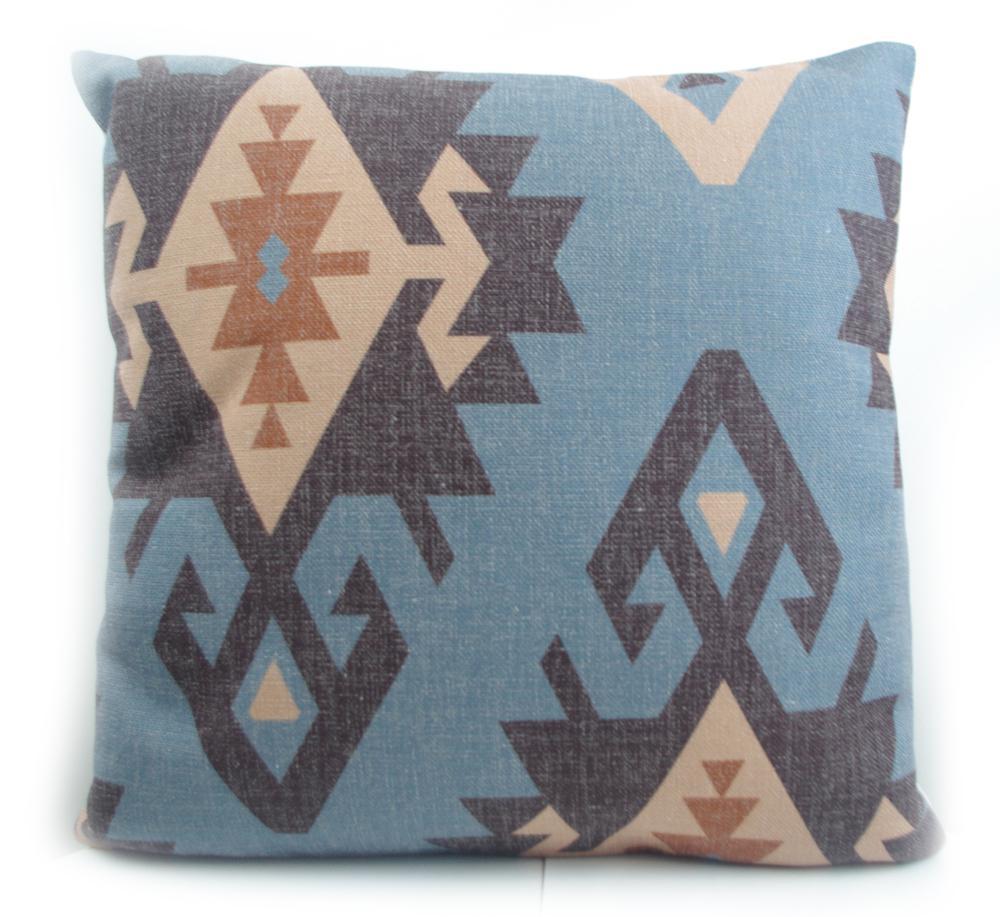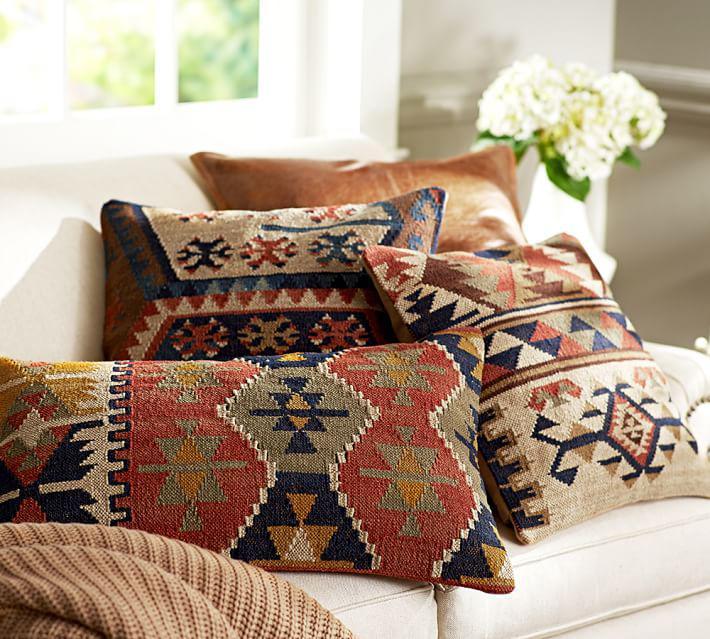The first image is the image on the left, the second image is the image on the right. Assess this claim about the two images: "In at least one image there is only a single pillow standing up with some triangle patterns sewn into it.". Correct or not? Answer yes or no. Yes. The first image is the image on the left, the second image is the image on the right. Assess this claim about the two images: "One image contains a single square pillow with Aztec-style geometric print, and the other image contains at least three pillows with coordinating geometric prints.". Correct or not? Answer yes or no. Yes. 